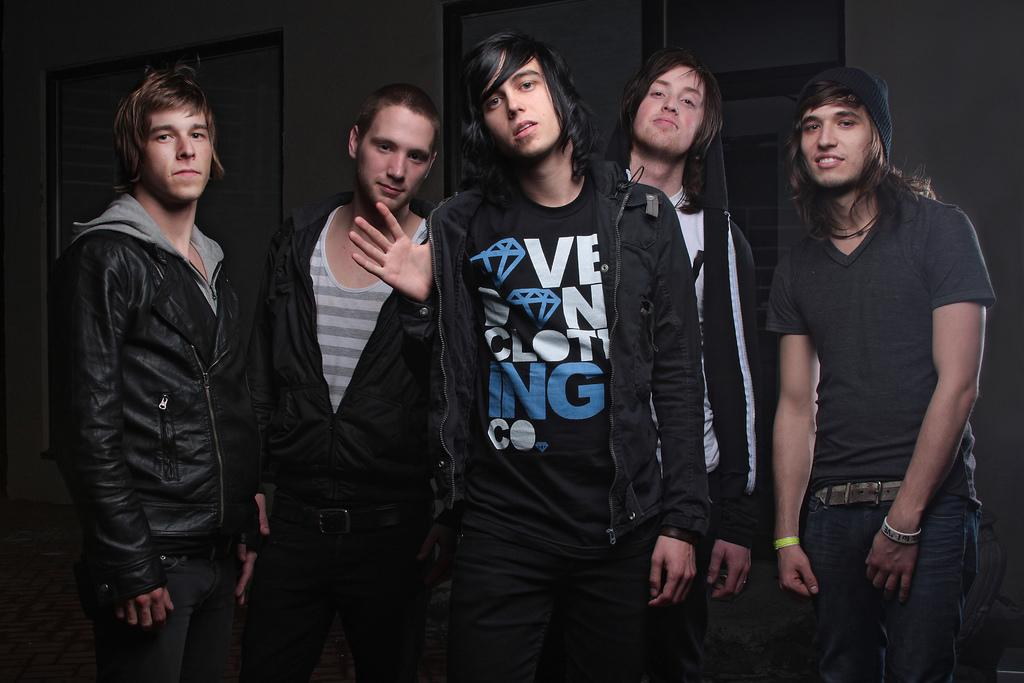How many boys are in the group in the image? There is a group of five boys in the middle of the image. What can be seen in the background of the image? There is a wall in the background of the image. Where is the door located in the image? The door is on the left side of the image. What part of the wall did the boys smash in the image? There is no indication in the image that the boys smashed any part of the wall. 